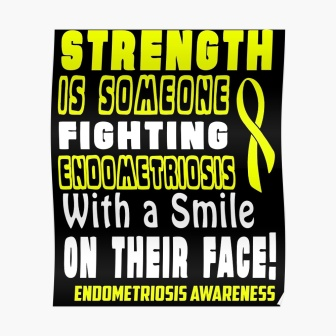Analyze the image in a comprehensive and detailed manner. The image is a black poster representing an awareness campaign for endometriosis. The poster features striking bold yellow text with different sizes to emphasize key messages. The largest text reads 'STRENGTH' at the top, which immediately catches the viewer's attention. Below it, another statement says 'IS SOMEONE FIGHTING ENDOMETRIOSIS With a Smile ON THEIR FACE!', which highlights both the condition and the resilience of those who deal with it daily. The word 'ENDOMETRIOSIS' is notably repeated in bold to emphasize the cause. A yellow ribbon adorns the right side of the poster, which is a universal symbol for awareness, especially for endometriosis in this context. At the bottom right corner, the text 'AWARENESS' further clarifies the poster's intent. The high contrast between the bold yellow text and the black background makes the message stand out effectively, aiming to both inform and inspire strength in the face of this chronic illness. 